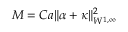Convert formula to latex. <formula><loc_0><loc_0><loc_500><loc_500>M = C a \| \alpha + \kappa \| _ { W ^ { 1 , \infty } } ^ { 2 }</formula> 